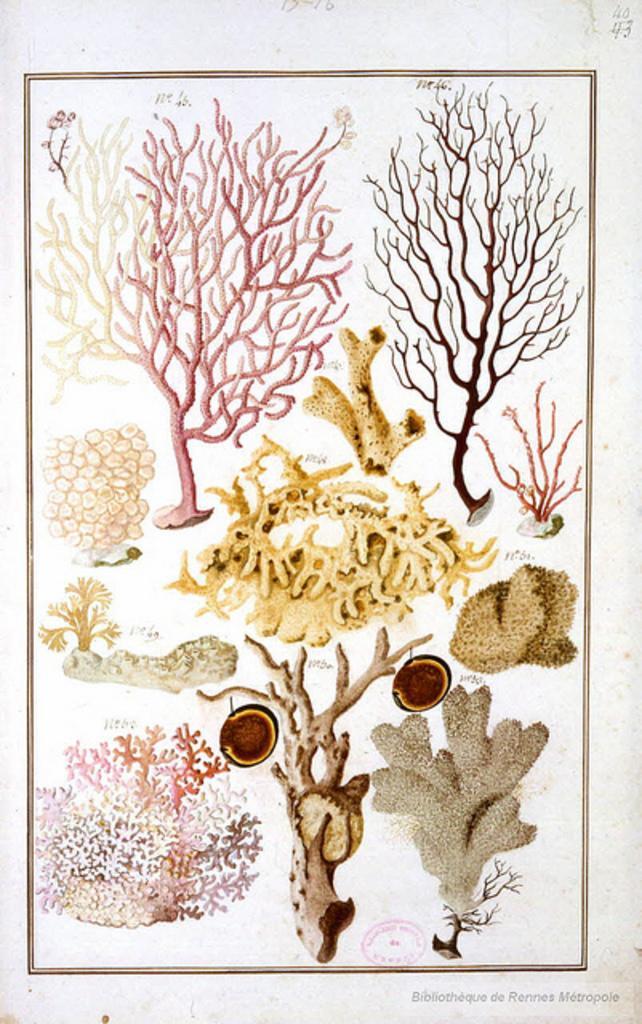Can you describe this image briefly? In this picture I can observe different types of trees in the paper. The paper is in white color. I can observe a border in this paper. The background is in white color. 